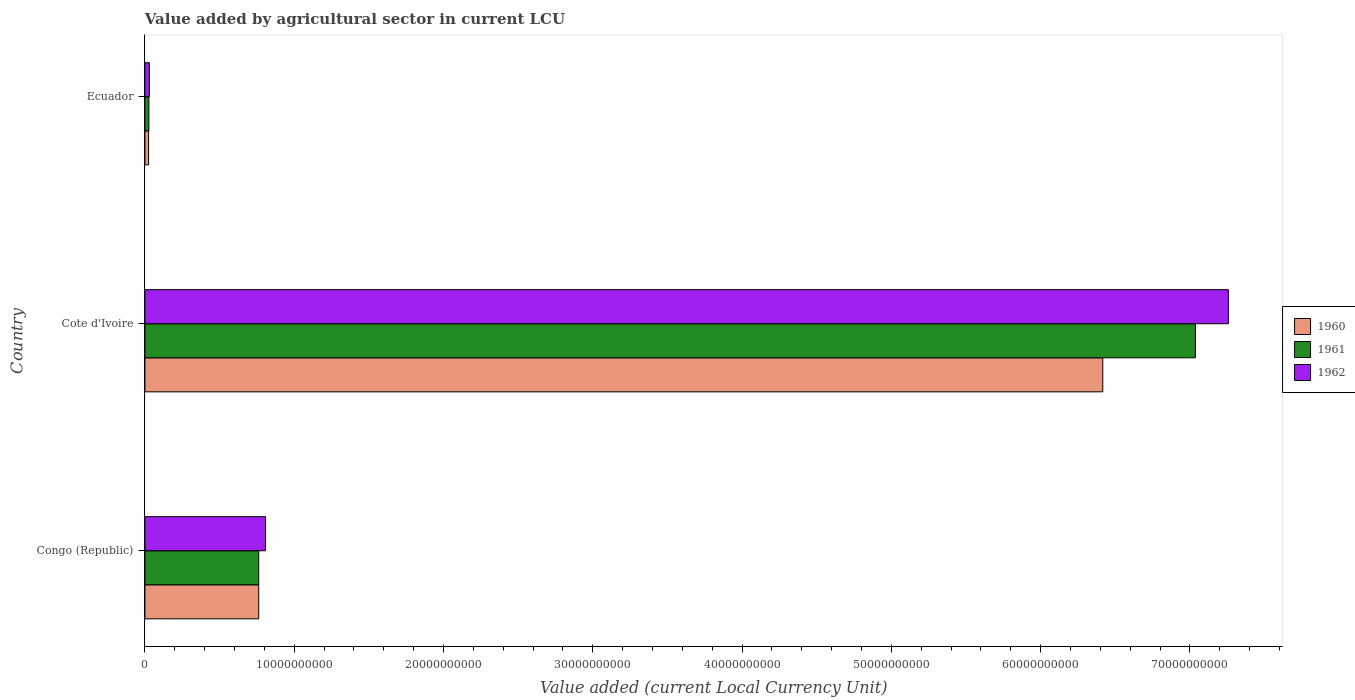How many different coloured bars are there?
Your response must be concise. 3. Are the number of bars on each tick of the Y-axis equal?
Ensure brevity in your answer.  Yes. How many bars are there on the 2nd tick from the bottom?
Ensure brevity in your answer.  3. What is the label of the 2nd group of bars from the top?
Keep it short and to the point. Cote d'Ivoire. In how many cases, is the number of bars for a given country not equal to the number of legend labels?
Your answer should be compact. 0. What is the value added by agricultural sector in 1960 in Ecuador?
Keep it short and to the point. 2.45e+08. Across all countries, what is the maximum value added by agricultural sector in 1962?
Ensure brevity in your answer.  7.26e+1. Across all countries, what is the minimum value added by agricultural sector in 1960?
Ensure brevity in your answer.  2.45e+08. In which country was the value added by agricultural sector in 1960 maximum?
Ensure brevity in your answer.  Cote d'Ivoire. In which country was the value added by agricultural sector in 1960 minimum?
Offer a very short reply. Ecuador. What is the total value added by agricultural sector in 1960 in the graph?
Your response must be concise. 7.20e+1. What is the difference between the value added by agricultural sector in 1960 in Congo (Republic) and that in Cote d'Ivoire?
Provide a short and direct response. -5.65e+1. What is the difference between the value added by agricultural sector in 1961 in Congo (Republic) and the value added by agricultural sector in 1962 in Cote d'Ivoire?
Your answer should be very brief. -6.50e+1. What is the average value added by agricultural sector in 1960 per country?
Your answer should be very brief. 2.40e+1. What is the difference between the value added by agricultural sector in 1962 and value added by agricultural sector in 1961 in Cote d'Ivoire?
Your answer should be very brief. 2.21e+09. In how many countries, is the value added by agricultural sector in 1960 greater than 18000000000 LCU?
Keep it short and to the point. 1. What is the ratio of the value added by agricultural sector in 1960 in Congo (Republic) to that in Ecuador?
Make the answer very short. 31.08. What is the difference between the highest and the second highest value added by agricultural sector in 1960?
Keep it short and to the point. 5.65e+1. What is the difference between the highest and the lowest value added by agricultural sector in 1961?
Keep it short and to the point. 7.01e+1. In how many countries, is the value added by agricultural sector in 1960 greater than the average value added by agricultural sector in 1960 taken over all countries?
Offer a terse response. 1. Is the sum of the value added by agricultural sector in 1960 in Cote d'Ivoire and Ecuador greater than the maximum value added by agricultural sector in 1962 across all countries?
Make the answer very short. No. What does the 2nd bar from the bottom in Ecuador represents?
Your answer should be very brief. 1961. Is it the case that in every country, the sum of the value added by agricultural sector in 1962 and value added by agricultural sector in 1960 is greater than the value added by agricultural sector in 1961?
Offer a very short reply. Yes. How many bars are there?
Your answer should be very brief. 9. How many countries are there in the graph?
Your response must be concise. 3. What is the difference between two consecutive major ticks on the X-axis?
Make the answer very short. 1.00e+1. Does the graph contain grids?
Keep it short and to the point. No. How many legend labels are there?
Offer a very short reply. 3. What is the title of the graph?
Your answer should be compact. Value added by agricultural sector in current LCU. Does "1984" appear as one of the legend labels in the graph?
Your answer should be very brief. No. What is the label or title of the X-axis?
Provide a succinct answer. Value added (current Local Currency Unit). What is the Value added (current Local Currency Unit) in 1960 in Congo (Republic)?
Provide a succinct answer. 7.62e+09. What is the Value added (current Local Currency Unit) in 1961 in Congo (Republic)?
Provide a short and direct response. 7.62e+09. What is the Value added (current Local Currency Unit) of 1962 in Congo (Republic)?
Provide a succinct answer. 8.08e+09. What is the Value added (current Local Currency Unit) of 1960 in Cote d'Ivoire?
Keep it short and to the point. 6.42e+1. What is the Value added (current Local Currency Unit) of 1961 in Cote d'Ivoire?
Your answer should be very brief. 7.04e+1. What is the Value added (current Local Currency Unit) of 1962 in Cote d'Ivoire?
Your answer should be compact. 7.26e+1. What is the Value added (current Local Currency Unit) in 1960 in Ecuador?
Keep it short and to the point. 2.45e+08. What is the Value added (current Local Currency Unit) of 1961 in Ecuador?
Offer a terse response. 2.66e+08. What is the Value added (current Local Currency Unit) in 1962 in Ecuador?
Keep it short and to the point. 2.95e+08. Across all countries, what is the maximum Value added (current Local Currency Unit) in 1960?
Provide a succinct answer. 6.42e+1. Across all countries, what is the maximum Value added (current Local Currency Unit) of 1961?
Provide a short and direct response. 7.04e+1. Across all countries, what is the maximum Value added (current Local Currency Unit) in 1962?
Give a very brief answer. 7.26e+1. Across all countries, what is the minimum Value added (current Local Currency Unit) in 1960?
Ensure brevity in your answer.  2.45e+08. Across all countries, what is the minimum Value added (current Local Currency Unit) in 1961?
Keep it short and to the point. 2.66e+08. Across all countries, what is the minimum Value added (current Local Currency Unit) of 1962?
Offer a terse response. 2.95e+08. What is the total Value added (current Local Currency Unit) of 1960 in the graph?
Your response must be concise. 7.20e+1. What is the total Value added (current Local Currency Unit) in 1961 in the graph?
Your answer should be very brief. 7.83e+1. What is the total Value added (current Local Currency Unit) of 1962 in the graph?
Offer a very short reply. 8.10e+1. What is the difference between the Value added (current Local Currency Unit) in 1960 in Congo (Republic) and that in Cote d'Ivoire?
Ensure brevity in your answer.  -5.65e+1. What is the difference between the Value added (current Local Currency Unit) in 1961 in Congo (Republic) and that in Cote d'Ivoire?
Keep it short and to the point. -6.27e+1. What is the difference between the Value added (current Local Currency Unit) in 1962 in Congo (Republic) and that in Cote d'Ivoire?
Ensure brevity in your answer.  -6.45e+1. What is the difference between the Value added (current Local Currency Unit) in 1960 in Congo (Republic) and that in Ecuador?
Make the answer very short. 7.38e+09. What is the difference between the Value added (current Local Currency Unit) in 1961 in Congo (Republic) and that in Ecuador?
Offer a very short reply. 7.36e+09. What is the difference between the Value added (current Local Currency Unit) of 1962 in Congo (Republic) and that in Ecuador?
Ensure brevity in your answer.  7.79e+09. What is the difference between the Value added (current Local Currency Unit) in 1960 in Cote d'Ivoire and that in Ecuador?
Provide a short and direct response. 6.39e+1. What is the difference between the Value added (current Local Currency Unit) in 1961 in Cote d'Ivoire and that in Ecuador?
Your answer should be very brief. 7.01e+1. What is the difference between the Value added (current Local Currency Unit) of 1962 in Cote d'Ivoire and that in Ecuador?
Your response must be concise. 7.23e+1. What is the difference between the Value added (current Local Currency Unit) of 1960 in Congo (Republic) and the Value added (current Local Currency Unit) of 1961 in Cote d'Ivoire?
Your response must be concise. -6.27e+1. What is the difference between the Value added (current Local Currency Unit) in 1960 in Congo (Republic) and the Value added (current Local Currency Unit) in 1962 in Cote d'Ivoire?
Ensure brevity in your answer.  -6.50e+1. What is the difference between the Value added (current Local Currency Unit) of 1961 in Congo (Republic) and the Value added (current Local Currency Unit) of 1962 in Cote d'Ivoire?
Offer a very short reply. -6.50e+1. What is the difference between the Value added (current Local Currency Unit) of 1960 in Congo (Republic) and the Value added (current Local Currency Unit) of 1961 in Ecuador?
Make the answer very short. 7.36e+09. What is the difference between the Value added (current Local Currency Unit) of 1960 in Congo (Republic) and the Value added (current Local Currency Unit) of 1962 in Ecuador?
Offer a terse response. 7.33e+09. What is the difference between the Value added (current Local Currency Unit) in 1961 in Congo (Republic) and the Value added (current Local Currency Unit) in 1962 in Ecuador?
Ensure brevity in your answer.  7.33e+09. What is the difference between the Value added (current Local Currency Unit) of 1960 in Cote d'Ivoire and the Value added (current Local Currency Unit) of 1961 in Ecuador?
Your answer should be very brief. 6.39e+1. What is the difference between the Value added (current Local Currency Unit) in 1960 in Cote d'Ivoire and the Value added (current Local Currency Unit) in 1962 in Ecuador?
Provide a succinct answer. 6.39e+1. What is the difference between the Value added (current Local Currency Unit) in 1961 in Cote d'Ivoire and the Value added (current Local Currency Unit) in 1962 in Ecuador?
Your answer should be very brief. 7.01e+1. What is the average Value added (current Local Currency Unit) of 1960 per country?
Your response must be concise. 2.40e+1. What is the average Value added (current Local Currency Unit) of 1961 per country?
Your answer should be very brief. 2.61e+1. What is the average Value added (current Local Currency Unit) of 1962 per country?
Make the answer very short. 2.70e+1. What is the difference between the Value added (current Local Currency Unit) of 1960 and Value added (current Local Currency Unit) of 1962 in Congo (Republic)?
Your answer should be compact. -4.57e+08. What is the difference between the Value added (current Local Currency Unit) in 1961 and Value added (current Local Currency Unit) in 1962 in Congo (Republic)?
Keep it short and to the point. -4.57e+08. What is the difference between the Value added (current Local Currency Unit) of 1960 and Value added (current Local Currency Unit) of 1961 in Cote d'Ivoire?
Keep it short and to the point. -6.21e+09. What is the difference between the Value added (current Local Currency Unit) in 1960 and Value added (current Local Currency Unit) in 1962 in Cote d'Ivoire?
Offer a very short reply. -8.41e+09. What is the difference between the Value added (current Local Currency Unit) of 1961 and Value added (current Local Currency Unit) of 1962 in Cote d'Ivoire?
Your response must be concise. -2.21e+09. What is the difference between the Value added (current Local Currency Unit) in 1960 and Value added (current Local Currency Unit) in 1961 in Ecuador?
Offer a very short reply. -2.09e+07. What is the difference between the Value added (current Local Currency Unit) in 1960 and Value added (current Local Currency Unit) in 1962 in Ecuador?
Provide a succinct answer. -4.98e+07. What is the difference between the Value added (current Local Currency Unit) in 1961 and Value added (current Local Currency Unit) in 1962 in Ecuador?
Provide a short and direct response. -2.89e+07. What is the ratio of the Value added (current Local Currency Unit) in 1960 in Congo (Republic) to that in Cote d'Ivoire?
Offer a terse response. 0.12. What is the ratio of the Value added (current Local Currency Unit) in 1961 in Congo (Republic) to that in Cote d'Ivoire?
Make the answer very short. 0.11. What is the ratio of the Value added (current Local Currency Unit) of 1962 in Congo (Republic) to that in Cote d'Ivoire?
Ensure brevity in your answer.  0.11. What is the ratio of the Value added (current Local Currency Unit) in 1960 in Congo (Republic) to that in Ecuador?
Provide a short and direct response. 31.08. What is the ratio of the Value added (current Local Currency Unit) of 1961 in Congo (Republic) to that in Ecuador?
Your answer should be very brief. 28.64. What is the ratio of the Value added (current Local Currency Unit) of 1962 in Congo (Republic) to that in Ecuador?
Give a very brief answer. 27.39. What is the ratio of the Value added (current Local Currency Unit) of 1960 in Cote d'Ivoire to that in Ecuador?
Provide a short and direct response. 261.58. What is the ratio of the Value added (current Local Currency Unit) of 1961 in Cote d'Ivoire to that in Ecuador?
Offer a very short reply. 264.35. What is the ratio of the Value added (current Local Currency Unit) in 1962 in Cote d'Ivoire to that in Ecuador?
Provide a short and direct response. 245.99. What is the difference between the highest and the second highest Value added (current Local Currency Unit) of 1960?
Offer a terse response. 5.65e+1. What is the difference between the highest and the second highest Value added (current Local Currency Unit) of 1961?
Your answer should be compact. 6.27e+1. What is the difference between the highest and the second highest Value added (current Local Currency Unit) in 1962?
Offer a terse response. 6.45e+1. What is the difference between the highest and the lowest Value added (current Local Currency Unit) of 1960?
Keep it short and to the point. 6.39e+1. What is the difference between the highest and the lowest Value added (current Local Currency Unit) of 1961?
Offer a very short reply. 7.01e+1. What is the difference between the highest and the lowest Value added (current Local Currency Unit) of 1962?
Make the answer very short. 7.23e+1. 